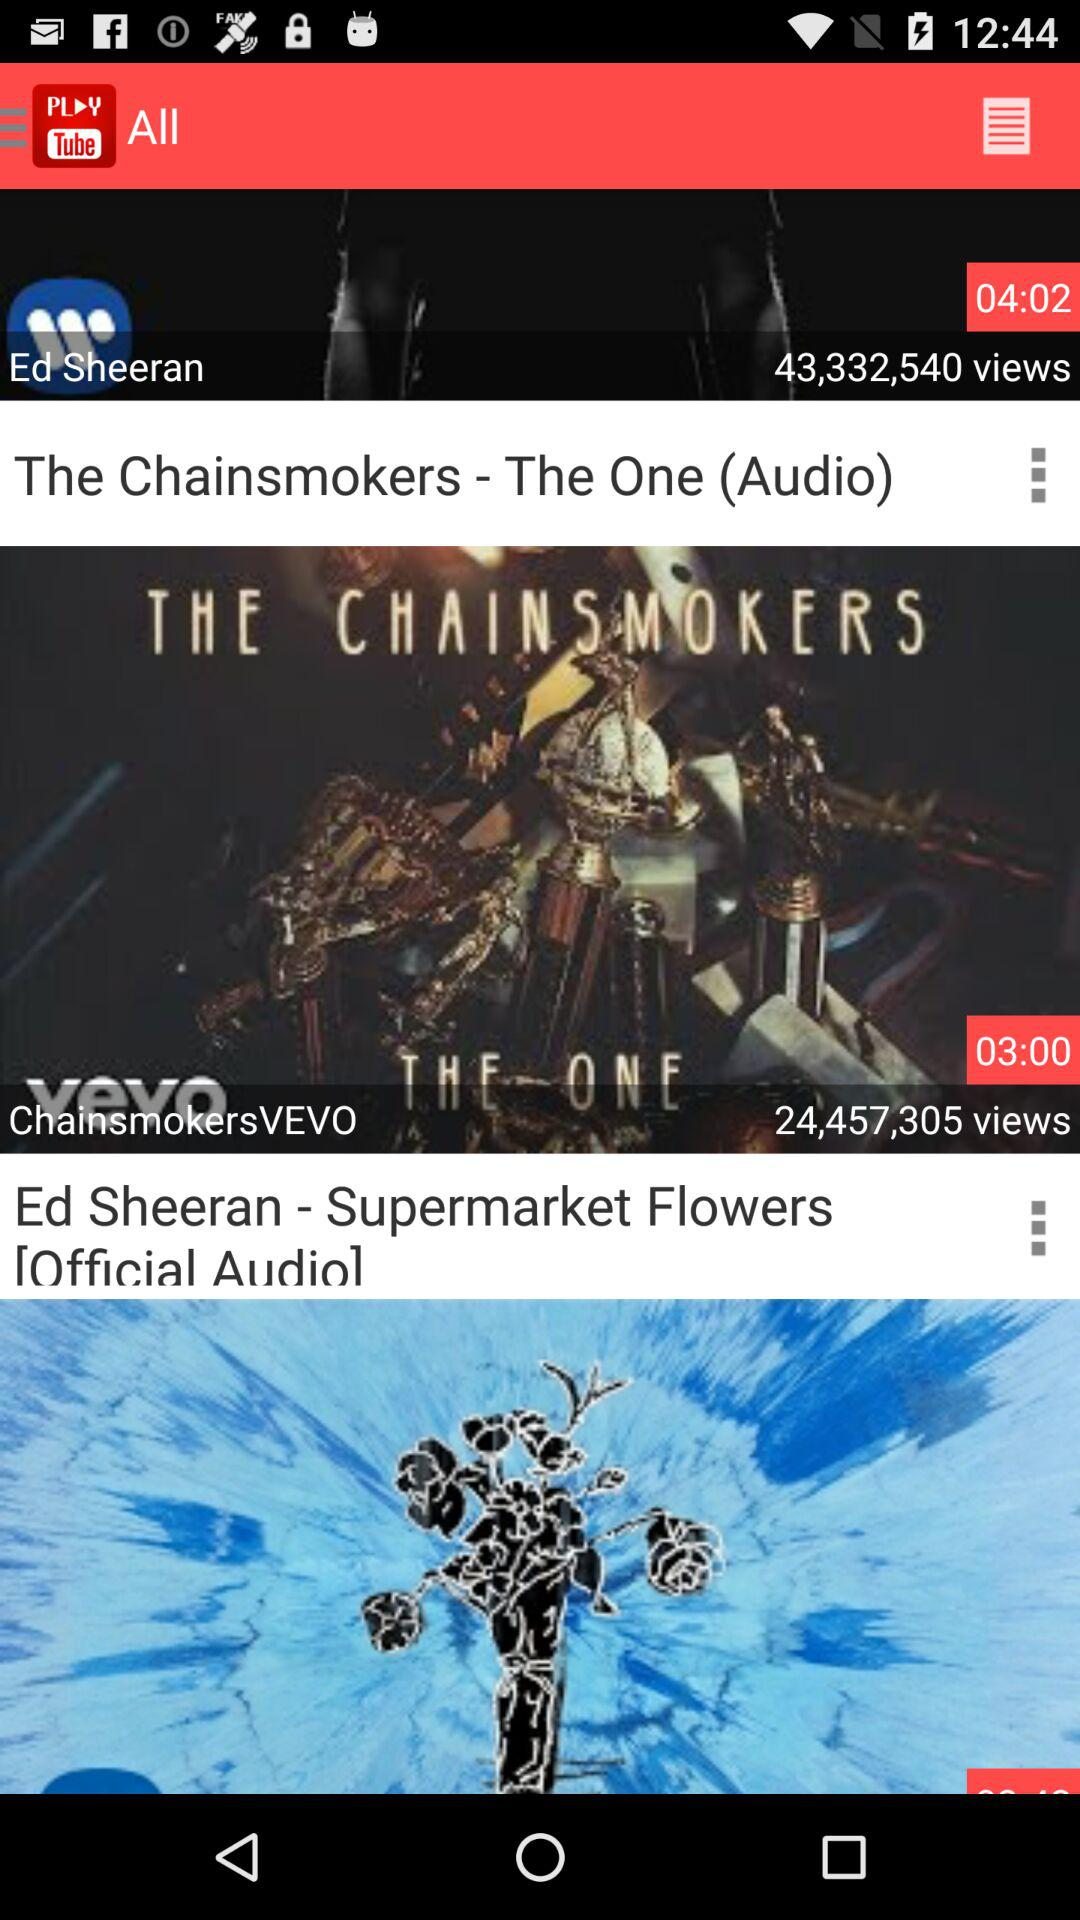How many views are there of "ChainsmokersVEVO"? There are 24,457,305 views of "ChainsmokersVEVO". 